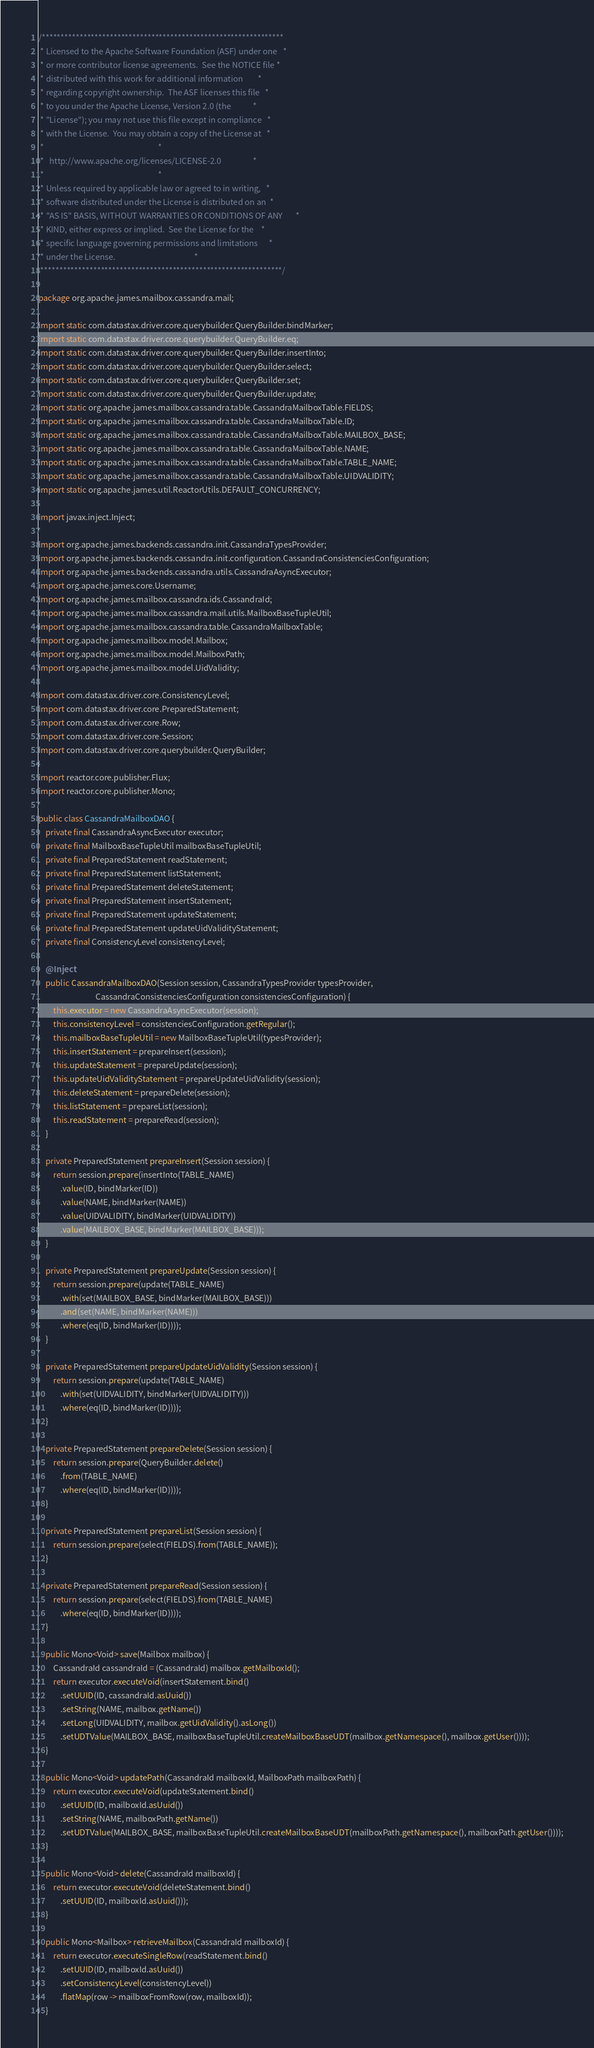<code> <loc_0><loc_0><loc_500><loc_500><_Java_>/****************************************************************
 * Licensed to the Apache Software Foundation (ASF) under one   *
 * or more contributor license agreements.  See the NOTICE file *
 * distributed with this work for additional information        *
 * regarding copyright ownership.  The ASF licenses this file   *
 * to you under the Apache License, Version 2.0 (the            *
 * "License"); you may not use this file except in compliance   *
 * with the License.  You may obtain a copy of the License at   *
 *                                                              *
 *   http://www.apache.org/licenses/LICENSE-2.0                 *
 *                                                              *
 * Unless required by applicable law or agreed to in writing,   *
 * software distributed under the License is distributed on an  *
 * "AS IS" BASIS, WITHOUT WARRANTIES OR CONDITIONS OF ANY       *
 * KIND, either express or implied.  See the License for the    *
 * specific language governing permissions and limitations      *
 * under the License.                                           *
 ****************************************************************/

package org.apache.james.mailbox.cassandra.mail;

import static com.datastax.driver.core.querybuilder.QueryBuilder.bindMarker;
import static com.datastax.driver.core.querybuilder.QueryBuilder.eq;
import static com.datastax.driver.core.querybuilder.QueryBuilder.insertInto;
import static com.datastax.driver.core.querybuilder.QueryBuilder.select;
import static com.datastax.driver.core.querybuilder.QueryBuilder.set;
import static com.datastax.driver.core.querybuilder.QueryBuilder.update;
import static org.apache.james.mailbox.cassandra.table.CassandraMailboxTable.FIELDS;
import static org.apache.james.mailbox.cassandra.table.CassandraMailboxTable.ID;
import static org.apache.james.mailbox.cassandra.table.CassandraMailboxTable.MAILBOX_BASE;
import static org.apache.james.mailbox.cassandra.table.CassandraMailboxTable.NAME;
import static org.apache.james.mailbox.cassandra.table.CassandraMailboxTable.TABLE_NAME;
import static org.apache.james.mailbox.cassandra.table.CassandraMailboxTable.UIDVALIDITY;
import static org.apache.james.util.ReactorUtils.DEFAULT_CONCURRENCY;

import javax.inject.Inject;

import org.apache.james.backends.cassandra.init.CassandraTypesProvider;
import org.apache.james.backends.cassandra.init.configuration.CassandraConsistenciesConfiguration;
import org.apache.james.backends.cassandra.utils.CassandraAsyncExecutor;
import org.apache.james.core.Username;
import org.apache.james.mailbox.cassandra.ids.CassandraId;
import org.apache.james.mailbox.cassandra.mail.utils.MailboxBaseTupleUtil;
import org.apache.james.mailbox.cassandra.table.CassandraMailboxTable;
import org.apache.james.mailbox.model.Mailbox;
import org.apache.james.mailbox.model.MailboxPath;
import org.apache.james.mailbox.model.UidValidity;

import com.datastax.driver.core.ConsistencyLevel;
import com.datastax.driver.core.PreparedStatement;
import com.datastax.driver.core.Row;
import com.datastax.driver.core.Session;
import com.datastax.driver.core.querybuilder.QueryBuilder;

import reactor.core.publisher.Flux;
import reactor.core.publisher.Mono;

public class CassandraMailboxDAO {
    private final CassandraAsyncExecutor executor;
    private final MailboxBaseTupleUtil mailboxBaseTupleUtil;
    private final PreparedStatement readStatement;
    private final PreparedStatement listStatement;
    private final PreparedStatement deleteStatement;
    private final PreparedStatement insertStatement;
    private final PreparedStatement updateStatement;
    private final PreparedStatement updateUidValidityStatement;
    private final ConsistencyLevel consistencyLevel;

    @Inject
    public CassandraMailboxDAO(Session session, CassandraTypesProvider typesProvider,
                               CassandraConsistenciesConfiguration consistenciesConfiguration) {
        this.executor = new CassandraAsyncExecutor(session);
        this.consistencyLevel = consistenciesConfiguration.getRegular();
        this.mailboxBaseTupleUtil = new MailboxBaseTupleUtil(typesProvider);
        this.insertStatement = prepareInsert(session);
        this.updateStatement = prepareUpdate(session);
        this.updateUidValidityStatement = prepareUpdateUidValidity(session);
        this.deleteStatement = prepareDelete(session);
        this.listStatement = prepareList(session);
        this.readStatement = prepareRead(session);
    }

    private PreparedStatement prepareInsert(Session session) {
        return session.prepare(insertInto(TABLE_NAME)
            .value(ID, bindMarker(ID))
            .value(NAME, bindMarker(NAME))
            .value(UIDVALIDITY, bindMarker(UIDVALIDITY))
            .value(MAILBOX_BASE, bindMarker(MAILBOX_BASE)));
    }

    private PreparedStatement prepareUpdate(Session session) {
        return session.prepare(update(TABLE_NAME)
            .with(set(MAILBOX_BASE, bindMarker(MAILBOX_BASE)))
            .and(set(NAME, bindMarker(NAME)))
            .where(eq(ID, bindMarker(ID))));
    }

    private PreparedStatement prepareUpdateUidValidity(Session session) {
        return session.prepare(update(TABLE_NAME)
            .with(set(UIDVALIDITY, bindMarker(UIDVALIDITY)))
            .where(eq(ID, bindMarker(ID))));
    }

    private PreparedStatement prepareDelete(Session session) {
        return session.prepare(QueryBuilder.delete()
            .from(TABLE_NAME)
            .where(eq(ID, bindMarker(ID))));
    }

    private PreparedStatement prepareList(Session session) {
        return session.prepare(select(FIELDS).from(TABLE_NAME));
    }

    private PreparedStatement prepareRead(Session session) {
        return session.prepare(select(FIELDS).from(TABLE_NAME)
            .where(eq(ID, bindMarker(ID))));
    }

    public Mono<Void> save(Mailbox mailbox) {
        CassandraId cassandraId = (CassandraId) mailbox.getMailboxId();
        return executor.executeVoid(insertStatement.bind()
            .setUUID(ID, cassandraId.asUuid())
            .setString(NAME, mailbox.getName())
            .setLong(UIDVALIDITY, mailbox.getUidValidity().asLong())
            .setUDTValue(MAILBOX_BASE, mailboxBaseTupleUtil.createMailboxBaseUDT(mailbox.getNamespace(), mailbox.getUser())));
    }

    public Mono<Void> updatePath(CassandraId mailboxId, MailboxPath mailboxPath) {
        return executor.executeVoid(updateStatement.bind()
            .setUUID(ID, mailboxId.asUuid())
            .setString(NAME, mailboxPath.getName())
            .setUDTValue(MAILBOX_BASE, mailboxBaseTupleUtil.createMailboxBaseUDT(mailboxPath.getNamespace(), mailboxPath.getUser())));
    }

    public Mono<Void> delete(CassandraId mailboxId) {
        return executor.executeVoid(deleteStatement.bind()
            .setUUID(ID, mailboxId.asUuid()));
    }

    public Mono<Mailbox> retrieveMailbox(CassandraId mailboxId) {
        return executor.executeSingleRow(readStatement.bind()
            .setUUID(ID, mailboxId.asUuid())
            .setConsistencyLevel(consistencyLevel))
            .flatMap(row -> mailboxFromRow(row, mailboxId));
    }
</code> 